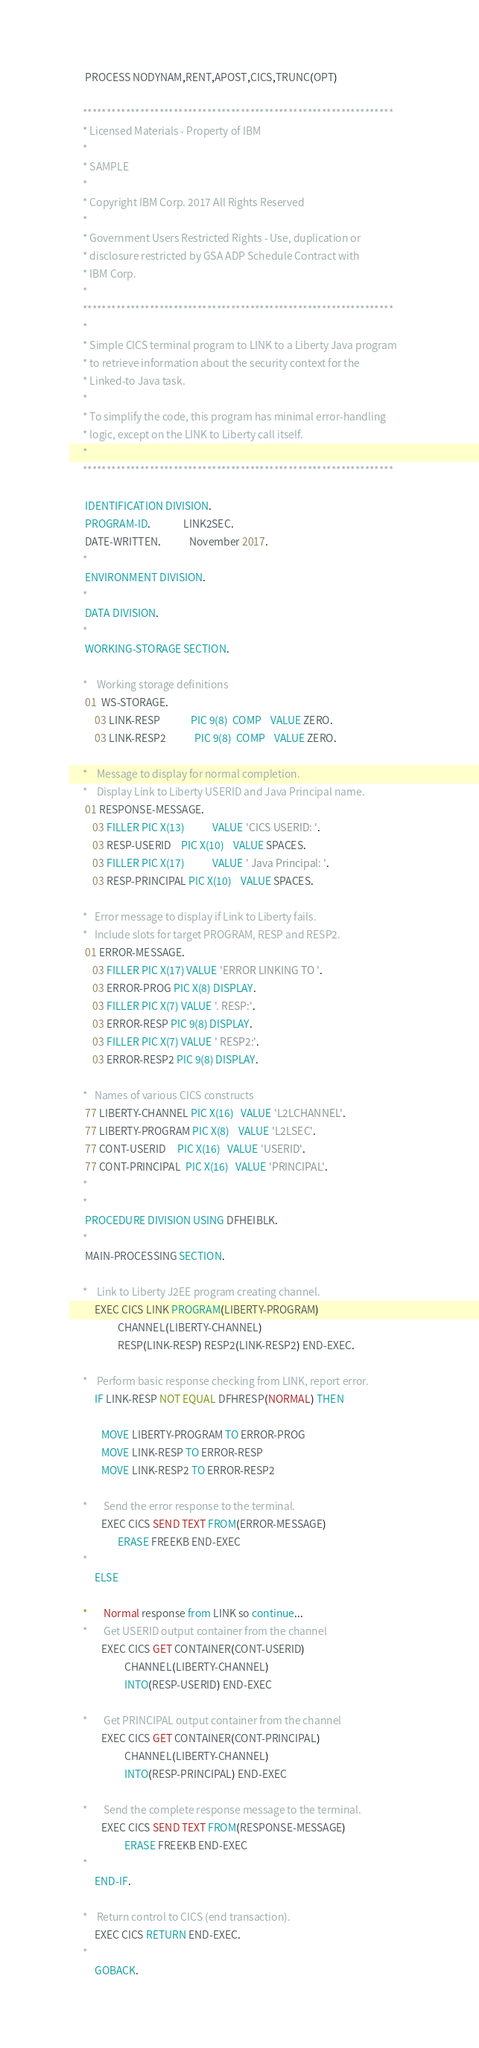Convert code to text. <code><loc_0><loc_0><loc_500><loc_500><_COBOL_>       PROCESS NODYNAM,RENT,APOST,CICS,TRUNC(OPT)

      *****************************************************************
      * Licensed Materials - Property of IBM
      *
      * SAMPLE
      *
      * Copyright IBM Corp. 2017 All Rights Reserved
      *
      * Government Users Restricted Rights - Use, duplication or
      * disclosure restricted by GSA ADP Schedule Contract with
      * IBM Corp.
      *
      *****************************************************************
      *
      * Simple CICS terminal program to LINK to a Liberty Java program		
      * to retrieve information about the security context for the
      * Linked-to Java task.
      *
      * To simplify the code, this program has minimal error-handling
      * logic, except on the LINK to Liberty call itself.
      *
      *****************************************************************

       IDENTIFICATION DIVISION.
       PROGRAM-ID.              LINK2SEC.
       DATE-WRITTEN.            November 2017.
      *
       ENVIRONMENT DIVISION.
      *
       DATA DIVISION.
      *
       WORKING-STORAGE SECTION.

      *    Working storage definitions
       01  WS-STORAGE.
           03 LINK-RESP             PIC 9(8)  COMP    VALUE ZERO.
           03 LINK-RESP2            PIC 9(8)  COMP    VALUE ZERO.

      *    Message to display for normal completion.
      *    Display Link to Liberty USERID and Java Principal name.
       01 RESPONSE-MESSAGE.
          03 FILLER PIC X(13)            VALUE 'CICS USERID: '.
          03 RESP-USERID    PIC X(10)    VALUE SPACES.
          03 FILLER PIC X(17)            VALUE ' Java Principal: '.
          03 RESP-PRINCIPAL PIC X(10)    VALUE SPACES.

      *   Error message to display if Link to Liberty fails.
      *   Include slots for target PROGRAM, RESP and RESP2.
       01 ERROR-MESSAGE.
          03 FILLER PIC X(17) VALUE 'ERROR LINKING TO '.
          03 ERROR-PROG PIC X(8) DISPLAY.
          03 FILLER PIC X(7) VALUE '. RESP:'.
          03 ERROR-RESP PIC 9(8) DISPLAY.
          03 FILLER PIC X(7) VALUE ' RESP2:'.
          03 ERROR-RESP2 PIC 9(8) DISPLAY.

      *   Names of various CICS constructs
       77 LIBERTY-CHANNEL PIC X(16)   VALUE 'L2LCHANNEL'.
       77 LIBERTY-PROGRAM PIC X(8)    VALUE 'L2LSEC'.
       77 CONT-USERID     PIC X(16)   VALUE 'USERID'.
       77 CONT-PRINCIPAL  PIC X(16)   VALUE 'PRINCIPAL'.
      *
      *
       PROCEDURE DIVISION USING DFHEIBLK.
      *
       MAIN-PROCESSING SECTION.

      *    Link to Liberty J2EE program creating channel.
           EXEC CICS LINK PROGRAM(LIBERTY-PROGRAM)
                     CHANNEL(LIBERTY-CHANNEL)
                     RESP(LINK-RESP) RESP2(LINK-RESP2) END-EXEC.

      *    Perform basic response checking from LINK, report error.
           IF LINK-RESP NOT EQUAL DFHRESP(NORMAL) THEN

              MOVE LIBERTY-PROGRAM TO ERROR-PROG
              MOVE LINK-RESP TO ERROR-RESP
              MOVE LINK-RESP2 TO ERROR-RESP2

      *       Send the error response to the terminal.
              EXEC CICS SEND TEXT FROM(ERROR-MESSAGE)
                     ERASE FREEKB END-EXEC
      * 
           ELSE

      *       Normal response from LINK so continue...
      *       Get USERID output container from the channel
              EXEC CICS GET CONTAINER(CONT-USERID)
                        CHANNEL(LIBERTY-CHANNEL)
                        INTO(RESP-USERID) END-EXEC

      *       Get PRINCIPAL output container from the channel
              EXEC CICS GET CONTAINER(CONT-PRINCIPAL)
                        CHANNEL(LIBERTY-CHANNEL)
                        INTO(RESP-PRINCIPAL) END-EXEC

      *       Send the complete response message to the terminal.
              EXEC CICS SEND TEXT FROM(RESPONSE-MESSAGE)
                        ERASE FREEKB END-EXEC
      *
           END-IF.

      *    Return control to CICS (end transaction).
           EXEC CICS RETURN END-EXEC.
      *
           GOBACK.

</code> 